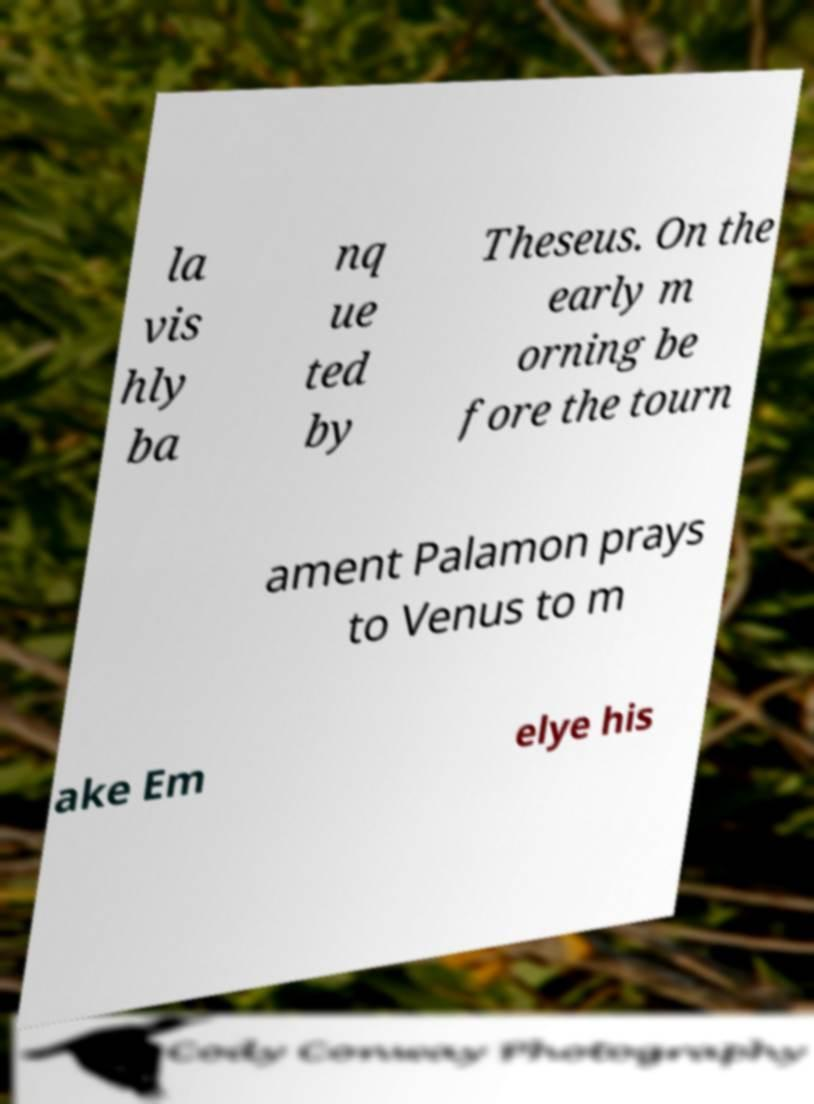Please read and relay the text visible in this image. What does it say? la vis hly ba nq ue ted by Theseus. On the early m orning be fore the tourn ament Palamon prays to Venus to m ake Em elye his 